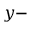<formula> <loc_0><loc_0><loc_500><loc_500>y -</formula> 